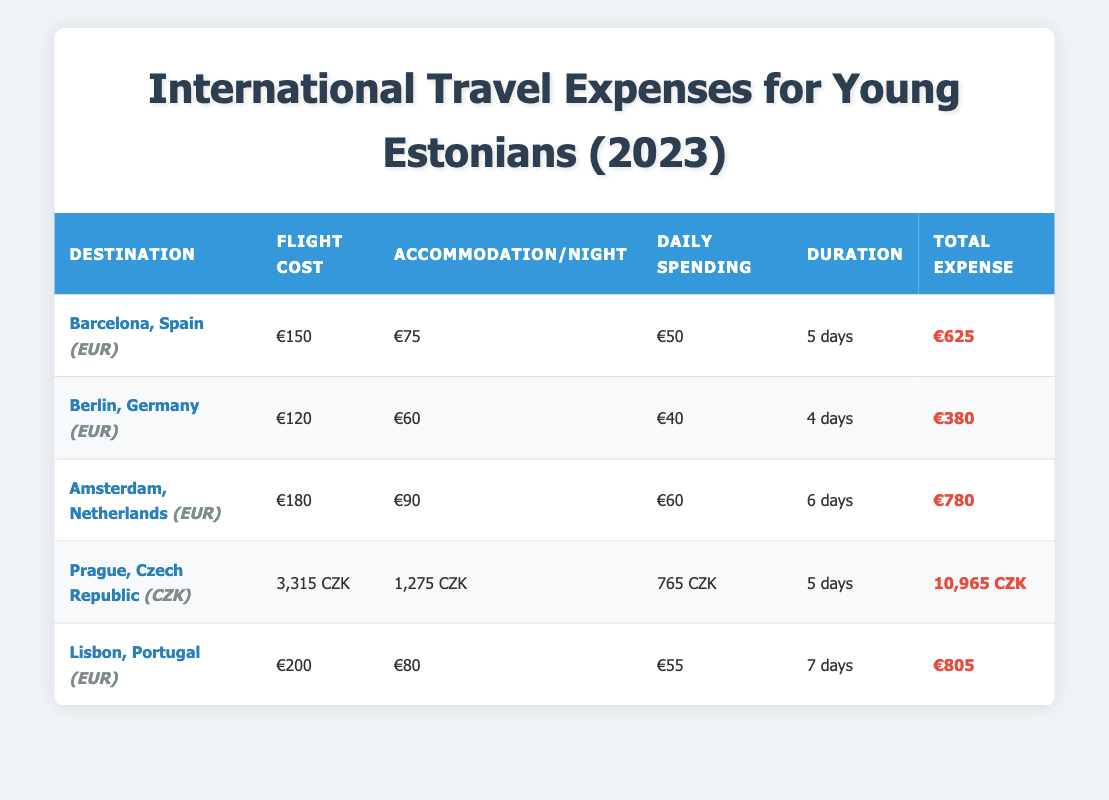What is the total expense for traveling to Barcelona, Spain? The total expense for traveling to Barcelona, Spain, can be found in the "Total Expense" column for that destination. It is listed as €625.
Answer: €625 What is the average daily spending in Amsterdam? The average daily spending in Amsterdam can be found in the "Daily Spending" column for that destination. It is listed as €60.
Answer: €60 Is the flight cost to Berlin cheaper than the flight cost to Barcelona? The flight cost to Berlin is €120, and the flight cost to Barcelona is €150. Since €120 is less than €150, the statement is true.
Answer: Yes What is the total expense for a 7-day stay in Lisbon? The total expense for a 7-day stay in Lisbon is found in the "Total Expense" column. It is €805.
Answer: €805 Which city has the highest flight cost, and what is that cost? The flight costs can be compared by looking at the "Flight Cost" column. The highest cost is €200 for Lisbon, Portugal.
Answer: Lisbon, €200 What is the total cost for a 5-day trip to Prague in CZK? The total cost is listed in the "Total Expense" column for Prague, which is 10,965 CZK.
Answer: 10,965 CZK If someone spent €50 per day for 6 days in Amsterdam, how would that compare to the average daily spending listed? The total for daily spending in Amsterdam would be €50 * 6 = €300. The average daily spending is €60. Comparing, €300 is less than the estimated total (Flight + Accommodation) in the table as the total is €780.
Answer: Less than average How much more does it cost to stay in Amsterdam compared to Berlin per night? The accommodation cost per night in Amsterdam is €90, and in Berlin, it is €60. The difference is €90 - €60 = €30.
Answer: €30 What is the total travel expense for all destinations combined? To find the total, add up all the total expenses: €625 (Barcelona) + €380 (Berlin) + €780 (Amsterdam) + 10,965 CZK (Prague) + €805 (Lisbon). Convert CZK to EUR for consistent units if needed, noting current exchange rates. The total is €2,590 assuming CZK is omitted for simplicity.
Answer: €2,590 